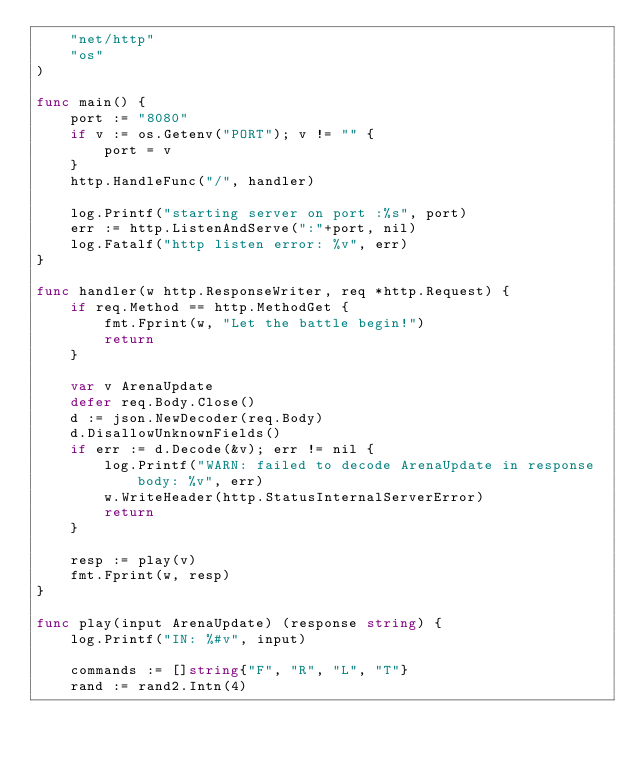<code> <loc_0><loc_0><loc_500><loc_500><_Go_>	"net/http"
	"os"
)

func main() {
	port := "8080"
	if v := os.Getenv("PORT"); v != "" {
		port = v
	}
	http.HandleFunc("/", handler)

	log.Printf("starting server on port :%s", port)
	err := http.ListenAndServe(":"+port, nil)
	log.Fatalf("http listen error: %v", err)
}

func handler(w http.ResponseWriter, req *http.Request) {
	if req.Method == http.MethodGet {
		fmt.Fprint(w, "Let the battle begin!")
		return
	}

	var v ArenaUpdate
	defer req.Body.Close()
	d := json.NewDecoder(req.Body)
	d.DisallowUnknownFields()
	if err := d.Decode(&v); err != nil {
		log.Printf("WARN: failed to decode ArenaUpdate in response body: %v", err)
		w.WriteHeader(http.StatusInternalServerError)
		return
	}

	resp := play(v)
	fmt.Fprint(w, resp)
}

func play(input ArenaUpdate) (response string) {
	log.Printf("IN: %#v", input)

	commands := []string{"F", "R", "L", "T"}
	rand := rand2.Intn(4)</code> 